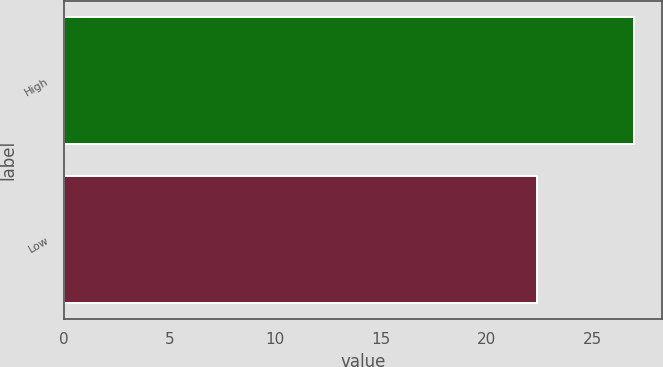<chart> <loc_0><loc_0><loc_500><loc_500><bar_chart><fcel>High<fcel>Low<nl><fcel>26.96<fcel>22.36<nl></chart> 